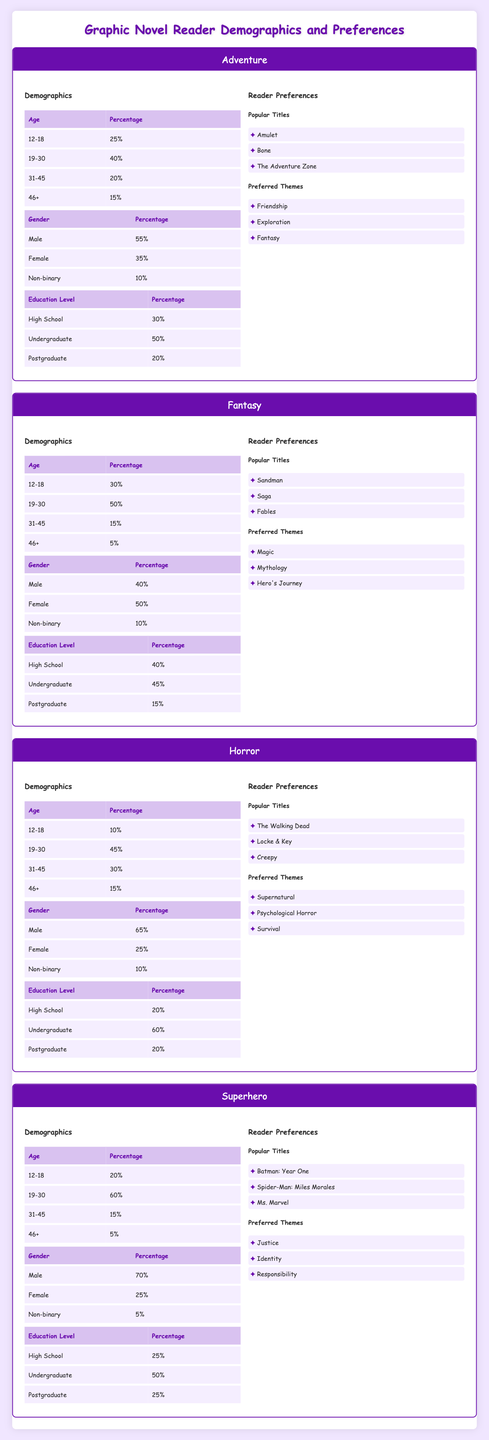What percentage of readers in the Adventure category are between the ages of 19-30? In the Adventure demographic table, under the Age category, the percentage of readers aged 19-30 is listed as 40%.
Answer: 40% What is the most popular title among Horror readers? In the Horror preferences section, the popular titles listed include "The Walking Dead," "Locke & Key," and "Creepy." Of these, "The Walking Dead" is often considered the most popular.
Answer: The Walking Dead Is the majority of Superhero readers male? In the Superhero demographic table under Gender, 70% of the readers are male, which indicates that the majority of readers in this category are indeed male.
Answer: Yes Which genre has the highest percentage of readers aged 31-45? By comparing the percentage of readers aged 31-45 across all genres, the Adventure genre has 20%, Fantasy has 15%, Horror has 30%, and Superhero has 15%. Therefore, Horror has the highest percentage at 30%.
Answer: Horror What is the average percentage of male readers across all categories? The percentage of male readers in each category is as follows: Adventure 55%, Fantasy 40%, Horror 65%, and Superhero 70%. To find the average, we sum these percentages (55 + 40 + 65 + 70) = 230 and divide by the number of categories (4), which gives an average male reader percentage of 57.5%.
Answer: 57.5% Which genre has the least representation of readers aged 46+? In the demographics for each genre, the percentages of readers aged 46+ are Adventure 15%, Fantasy 5%, Horror 15%, and Superhero 5%. Both Fantasy and Superhero genres have the least representation at 5%.
Answer: Fantasy and Superhero Are non-binary readers more prevalent in the Adventure genre than in the Fantasy genre? In the Adventure genre, non-binary readers make up 10%, while in the Fantasy genre, they also make up 10%. Therefore, the prevalence is equal, and neither genre has a higher percentage of non-binary readers than the other.
Answer: No What percentage of young adult readers (ages 12-18) prefer Fantasy over Adventure? In the Fantasy genre, the percentage of readers aged 12-18 is 30%, and in the Adventure genre, it is 25%. To determine how many more prefer Fantasy, we subtract the Adventure percentage from the Fantasy percentage (30 - 25) = 5%. Therefore, 5% more young adult readers prefer Fantasy.
Answer: 5% What is the total percentage of readers in the Horror category who are either 19-30 or 31-45? To find this, we add the percentages of readers in the Horror category for ages 19-30 (45%) and 31-45 (30%). Thus, the total is (45 + 30) = 75%.
Answer: 75% Which genre has the highest percentage of readers with postgraduate education? Looking at the percentages of postgraduate education across genres: Adventure has 20%, Fantasy has 15%, Horror has 20%, and Superhero has 25%. Therefore, Superhero has the highest percentage of postgraduate readers at 25%.
Answer: Superhero 